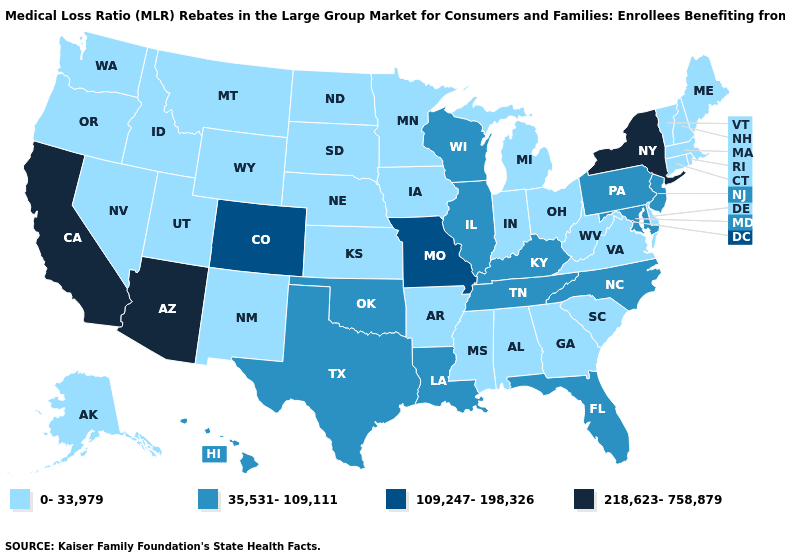What is the value of Georgia?
Give a very brief answer. 0-33,979. Among the states that border Ohio , which have the lowest value?
Short answer required. Indiana, Michigan, West Virginia. What is the value of Michigan?
Quick response, please. 0-33,979. What is the value of Alaska?
Be succinct. 0-33,979. Among the states that border Oregon , which have the highest value?
Be succinct. California. What is the lowest value in the West?
Answer briefly. 0-33,979. Name the states that have a value in the range 35,531-109,111?
Short answer required. Florida, Hawaii, Illinois, Kentucky, Louisiana, Maryland, New Jersey, North Carolina, Oklahoma, Pennsylvania, Tennessee, Texas, Wisconsin. What is the value of Louisiana?
Give a very brief answer. 35,531-109,111. Name the states that have a value in the range 109,247-198,326?
Keep it brief. Colorado, Missouri. Does the first symbol in the legend represent the smallest category?
Keep it brief. Yes. Name the states that have a value in the range 0-33,979?
Answer briefly. Alabama, Alaska, Arkansas, Connecticut, Delaware, Georgia, Idaho, Indiana, Iowa, Kansas, Maine, Massachusetts, Michigan, Minnesota, Mississippi, Montana, Nebraska, Nevada, New Hampshire, New Mexico, North Dakota, Ohio, Oregon, Rhode Island, South Carolina, South Dakota, Utah, Vermont, Virginia, Washington, West Virginia, Wyoming. What is the value of Virginia?
Write a very short answer. 0-33,979. What is the value of Massachusetts?
Keep it brief. 0-33,979. What is the lowest value in the Northeast?
Be succinct. 0-33,979. Does the map have missing data?
Quick response, please. No. 